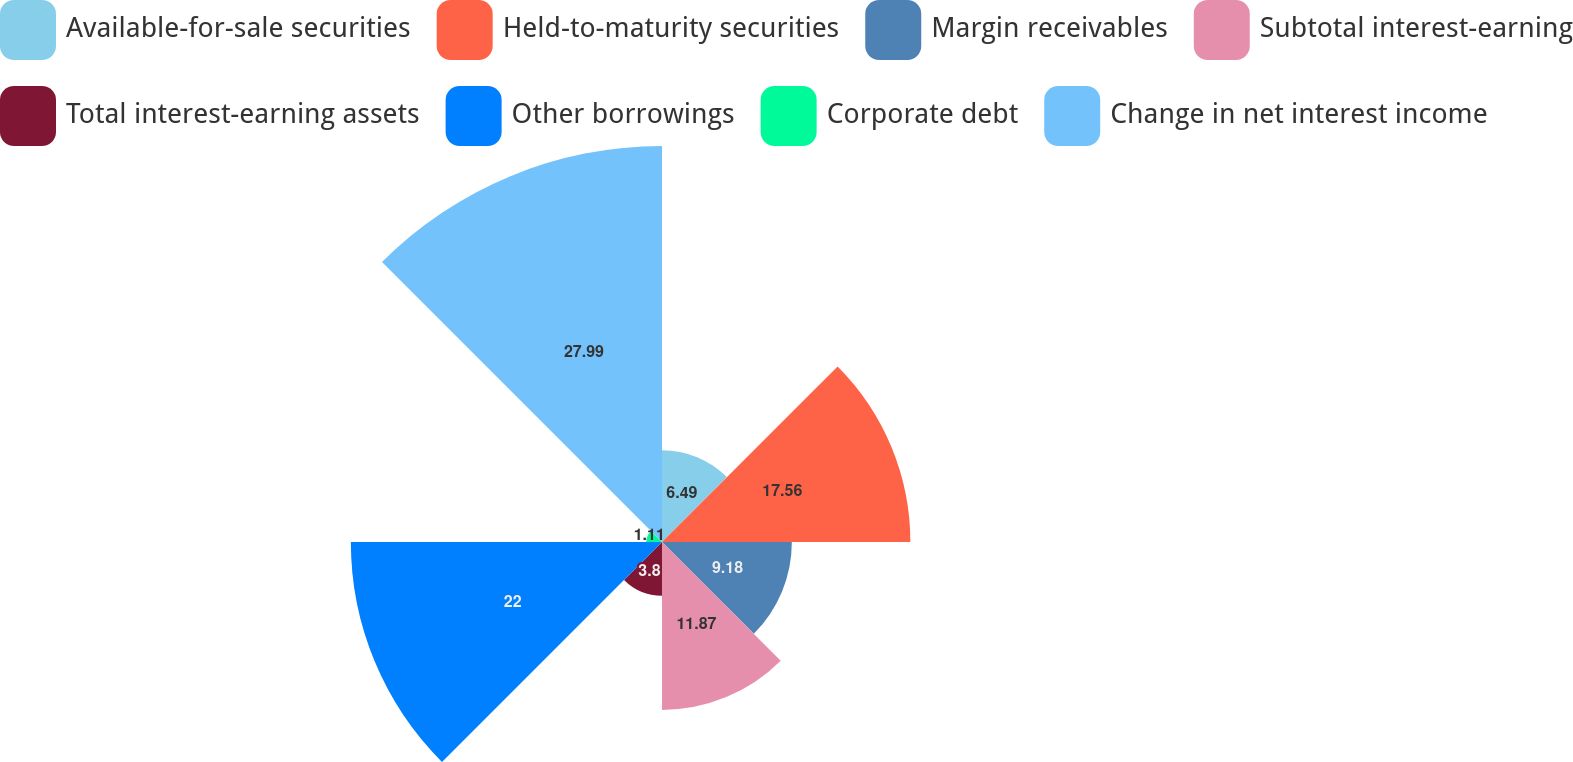Convert chart to OTSL. <chart><loc_0><loc_0><loc_500><loc_500><pie_chart><fcel>Available-for-sale securities<fcel>Held-to-maturity securities<fcel>Margin receivables<fcel>Subtotal interest-earning<fcel>Total interest-earning assets<fcel>Other borrowings<fcel>Corporate debt<fcel>Change in net interest income<nl><fcel>6.49%<fcel>17.56%<fcel>9.18%<fcel>11.87%<fcel>3.8%<fcel>22.0%<fcel>1.11%<fcel>28.0%<nl></chart> 